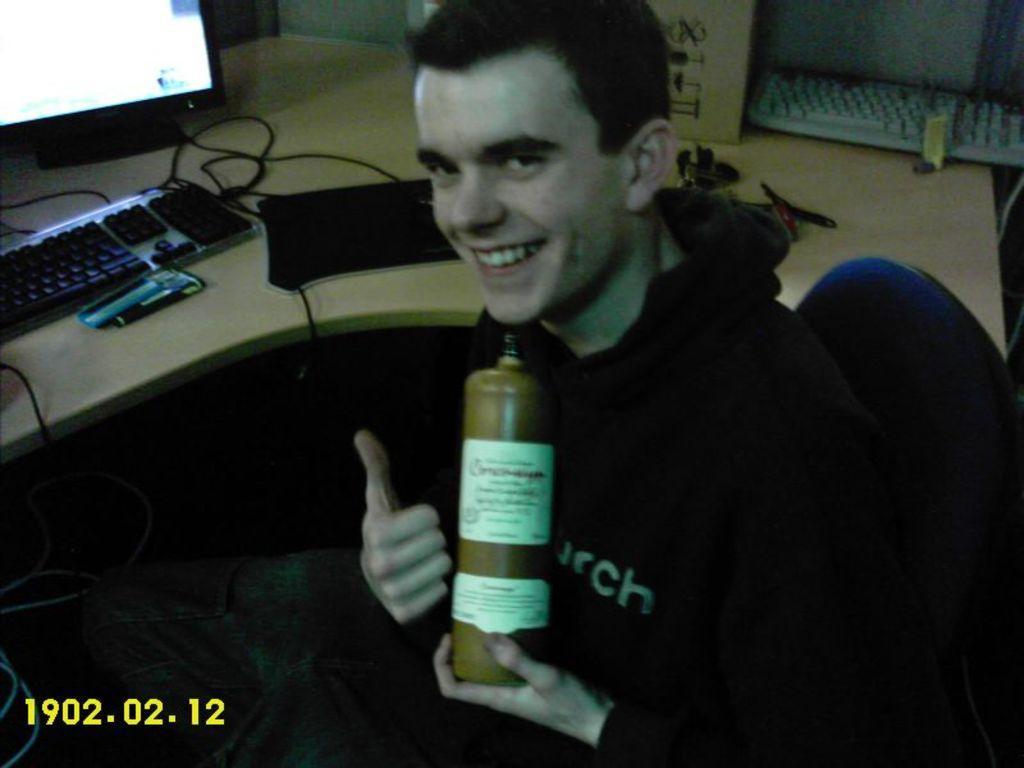Please provide a concise description of this image. This picture shows a man seated on the chair and holding a bottle in his hand and we see a computer on the table 